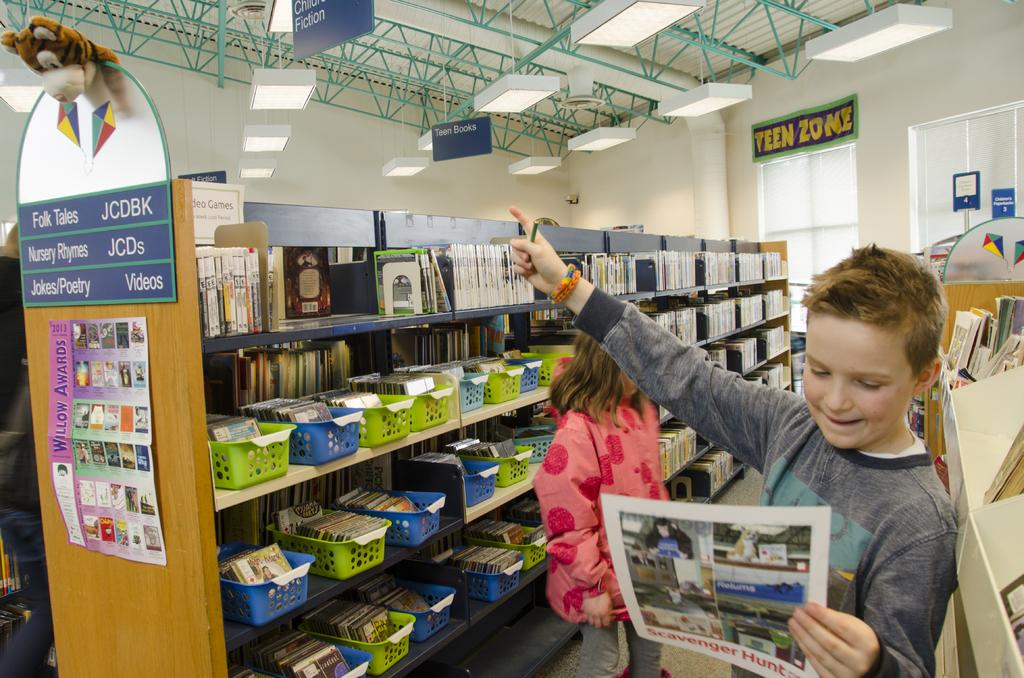Provide a one-sentence caption for the provided image. Boy is pointing at a stuffed animal in the "Teen Zone". 